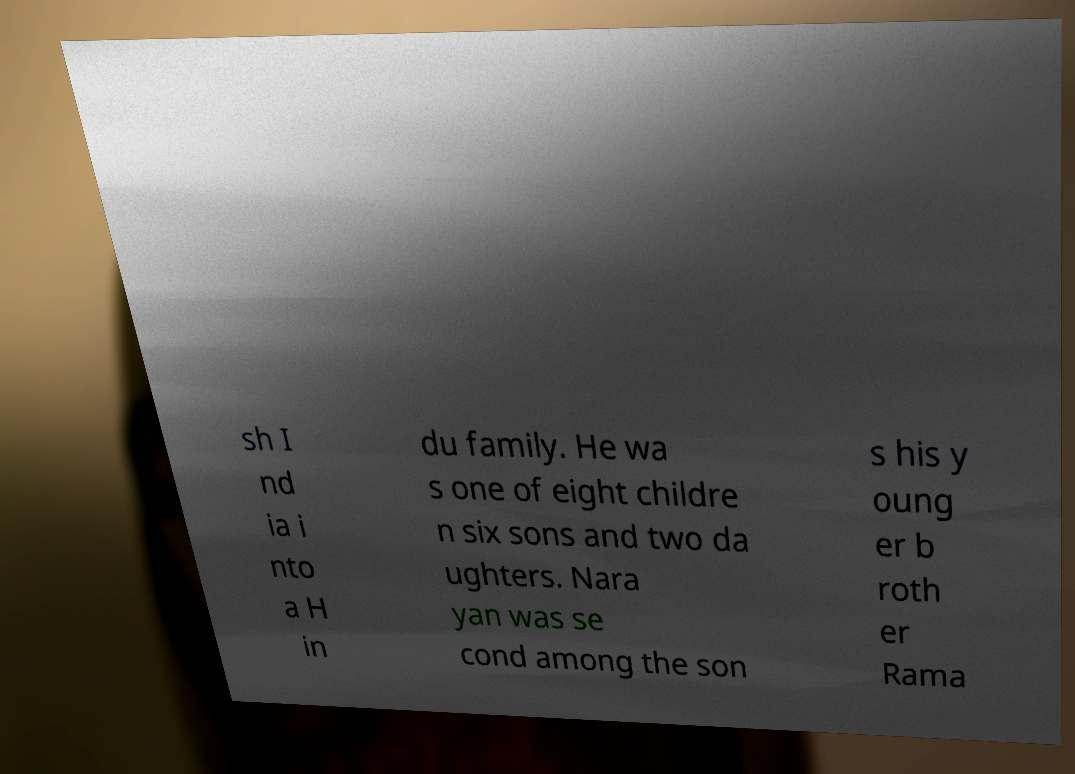Can you read and provide the text displayed in the image?This photo seems to have some interesting text. Can you extract and type it out for me? sh I nd ia i nto a H in du family. He wa s one of eight childre n six sons and two da ughters. Nara yan was se cond among the son s his y oung er b roth er Rama 